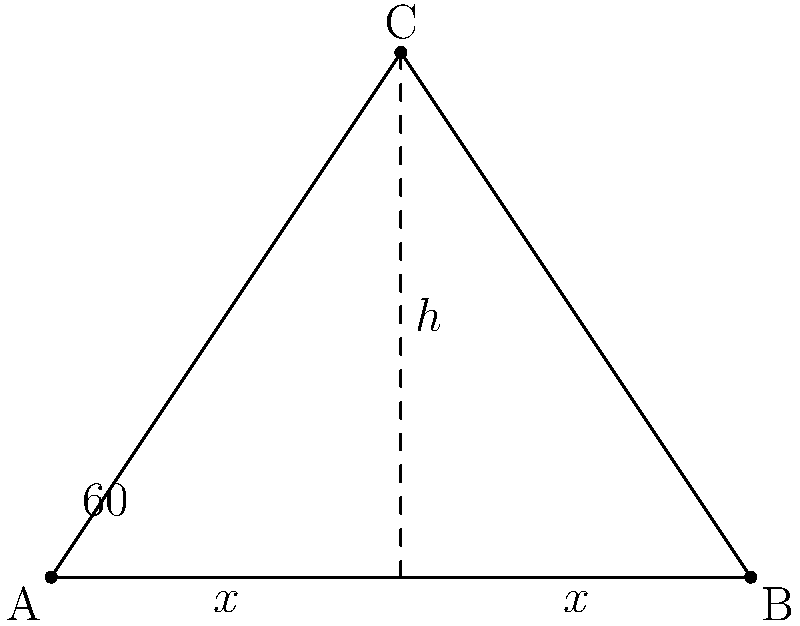In a conflict zone, you need to set up a secure communication triangle between three points: A, B, and C. The distance between A and B is 80 meters, and the angle at A is 60°. If the triangle is isosceles with AC = BC, what is the height (h) of the triangle to the nearest meter? Let's approach this step-by-step:

1) First, we recognize that this is an isosceles triangle where AC = BC.

2) The base of the triangle (AB) is 80 meters.

3) The angle at A is 60°.

4) Because it's isosceles, the height (h) bisects the base, creating two right triangles.

5) Let's focus on the right triangle formed by the height and half of the base:
   - The base of this right triangle is 40 meters (half of 80).
   - The angle at A is 30° (half of 60°).

6) In this right triangle, we can use the tangent function:

   $$\tan 30° = \frac{h}{40}$$

7) We know that $\tan 30° = \frac{1}{\sqrt{3}}$, so:

   $$\frac{1}{\sqrt{3}} = \frac{h}{40}$$

8) Cross multiply:

   $$40 = h\sqrt{3}$$

9) Solve for h:

   $$h = \frac{40}{\sqrt{3}} \approx 23.09$$

10) Rounding to the nearest meter:

    $$h \approx 23 \text{ meters}$$
Answer: 23 meters 